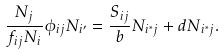<formula> <loc_0><loc_0><loc_500><loc_500>\frac { N _ { j } } { f _ { i j } N _ { i } } \phi _ { i j } N _ { i ^ { \prime } } = \frac { S _ { i j } } { b } N _ { i ^ { * } j } + d N _ { i ^ { * } j } .</formula> 